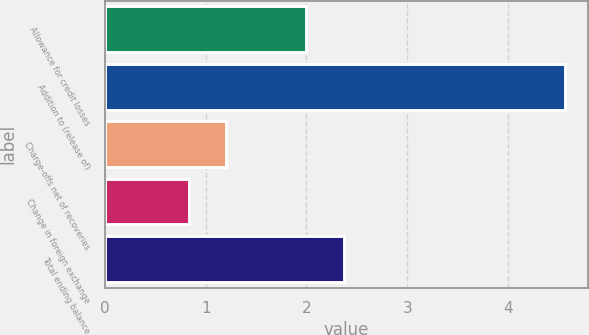Convert chart. <chart><loc_0><loc_0><loc_500><loc_500><bar_chart><fcel>Allowance for credit losses<fcel>Addition to (release of)<fcel>Charge-offs net of recoveries<fcel>Change in foreign exchange<fcel>Total ending balance<nl><fcel>2<fcel>4.57<fcel>1.2<fcel>0.83<fcel>2.37<nl></chart> 